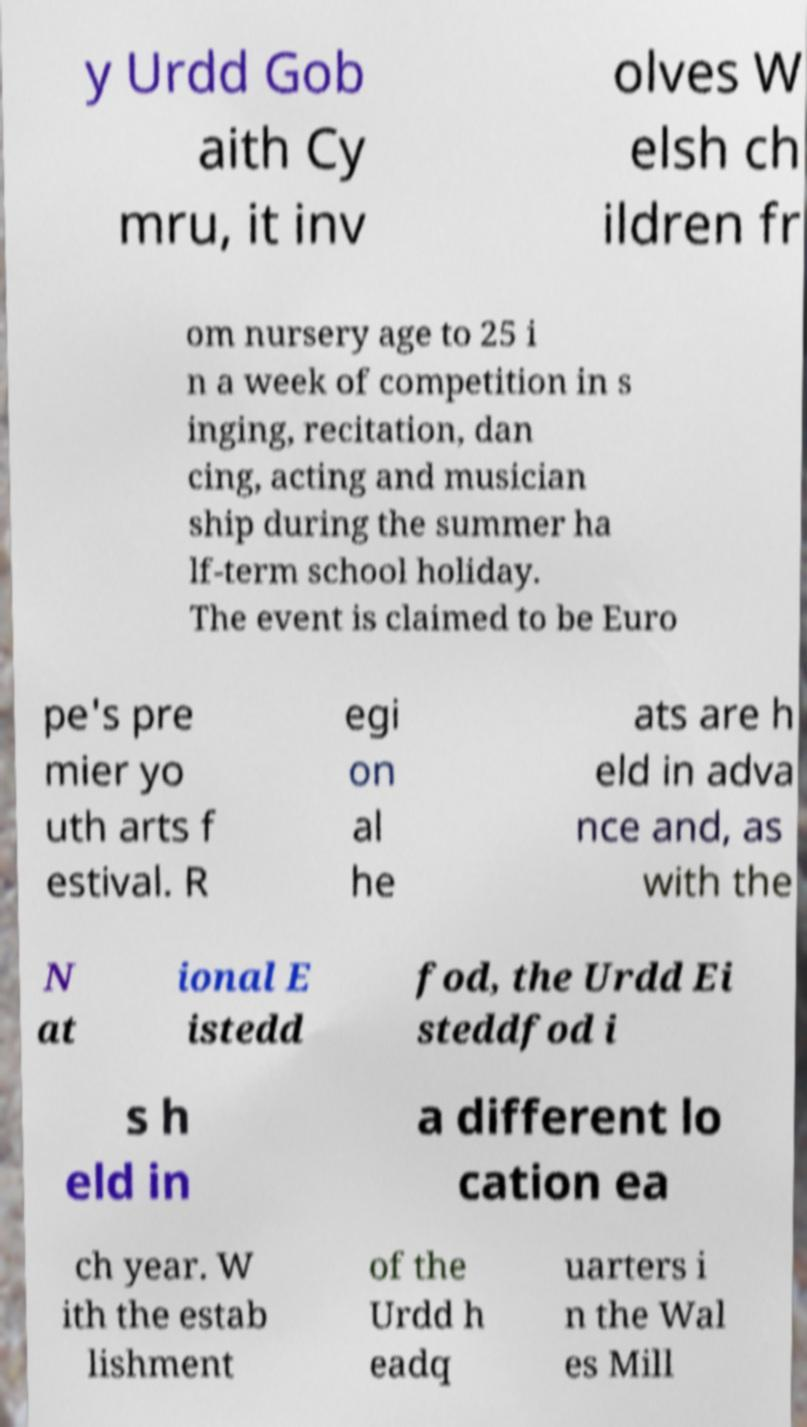Can you read and provide the text displayed in the image?This photo seems to have some interesting text. Can you extract and type it out for me? y Urdd Gob aith Cy mru, it inv olves W elsh ch ildren fr om nursery age to 25 i n a week of competition in s inging, recitation, dan cing, acting and musician ship during the summer ha lf-term school holiday. The event is claimed to be Euro pe's pre mier yo uth arts f estival. R egi on al he ats are h eld in adva nce and, as with the N at ional E istedd fod, the Urdd Ei steddfod i s h eld in a different lo cation ea ch year. W ith the estab lishment of the Urdd h eadq uarters i n the Wal es Mill 